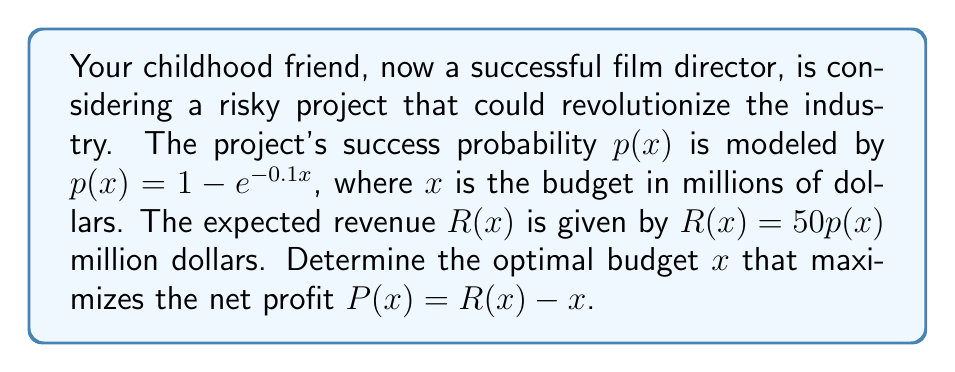Provide a solution to this math problem. Let's approach this step-by-step:

1) The net profit function is:
   $P(x) = R(x) - x = 50p(x) - x = 50(1 - e^{-0.1x}) - x$

2) To find the maximum, we need to differentiate $P(x)$ and set it to zero:
   $$\frac{dP}{dx} = 50(0.1e^{-0.1x}) - 1 = 5e^{-0.1x} - 1$$

3) Set this equal to zero:
   $5e^{-0.1x} - 1 = 0$

4) Solve for $x$:
   $5e^{-0.1x} = 1$
   $e^{-0.1x} = \frac{1}{5}$
   $-0.1x = \ln(\frac{1}{5})$
   $x = -10\ln(\frac{1}{5}) = 10\ln(5) \approx 16.09$

5) To confirm this is a maximum, we can check the second derivative:
   $$\frac{d^2P}{dx^2} = -0.5e^{-0.1x}$$
   This is always negative, confirming a maximum.

Therefore, the optimal budget is approximately $16.09 million dollars.
Answer: $16.09$ million dollars 